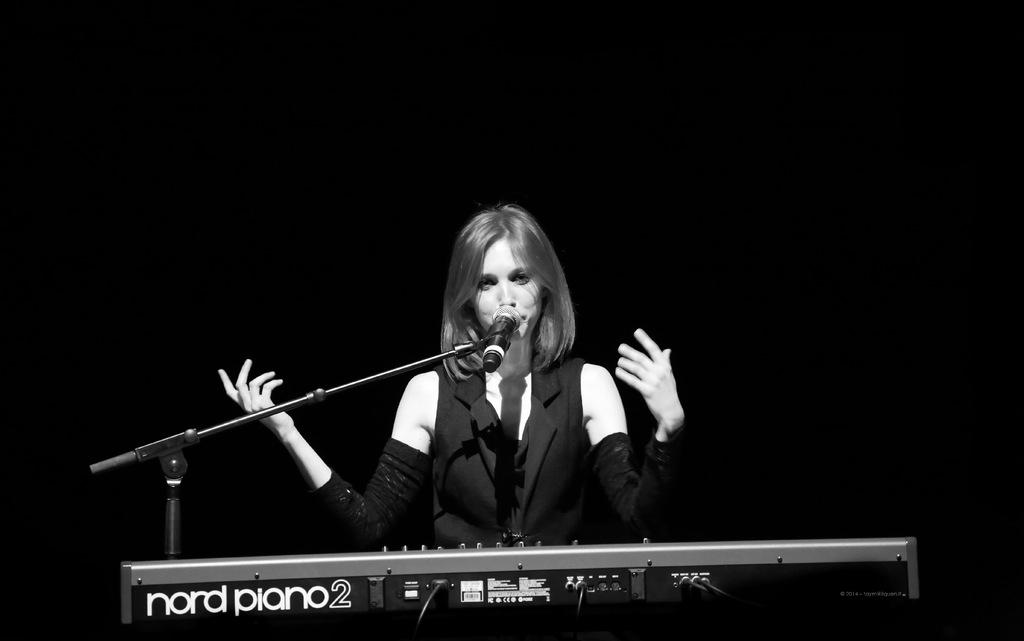Who is the main subject in the image? There is a woman in the image. What is the woman doing in the image? The woman is in front of a microphone and a piano. What can be seen in the background of the image? The background of the image is dark. What type of branch is the woman using to control the piano in the image? There is no branch present in the image, and the woman is not using any object to control the piano. 